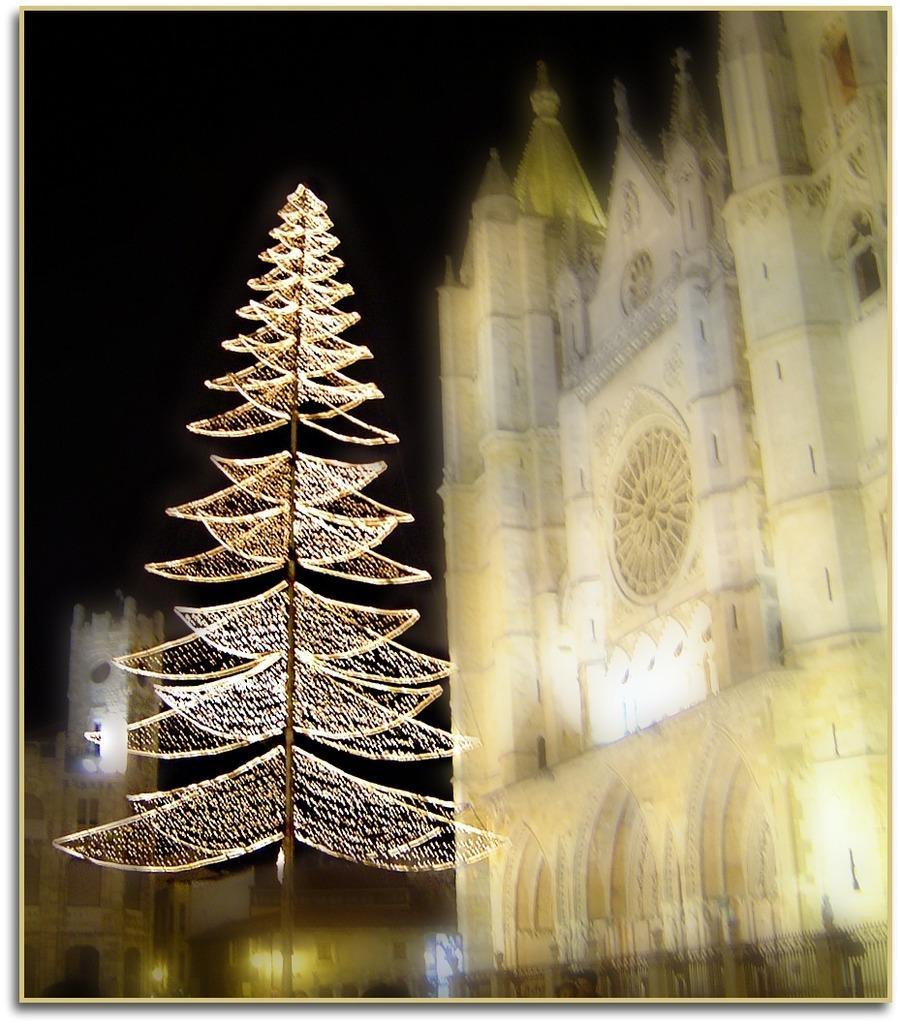Describe this image in one or two sentences. In this image we can see white color buildings and one tree like structure thing. 